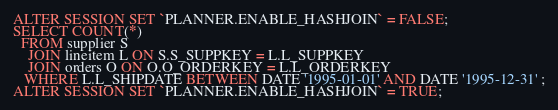<code> <loc_0><loc_0><loc_500><loc_500><_SQL_>ALTER SESSION SET `PLANNER.ENABLE_HASHJOIN` = FALSE;
SELECT COUNT(*)  
  FROM supplier S 
	JOIN lineitem L ON S.S_SUPPKEY = L.L_SUPPKEY 
    JOIN orders O ON O.O_ORDERKEY = L.L_ORDERKEY
   WHERE L.L_SHIPDATE BETWEEN DATE '1995-01-01' AND DATE '1995-12-31' ;
ALTER SESSION SET `PLANNER.ENABLE_HASHJOIN` = TRUE;
</code> 